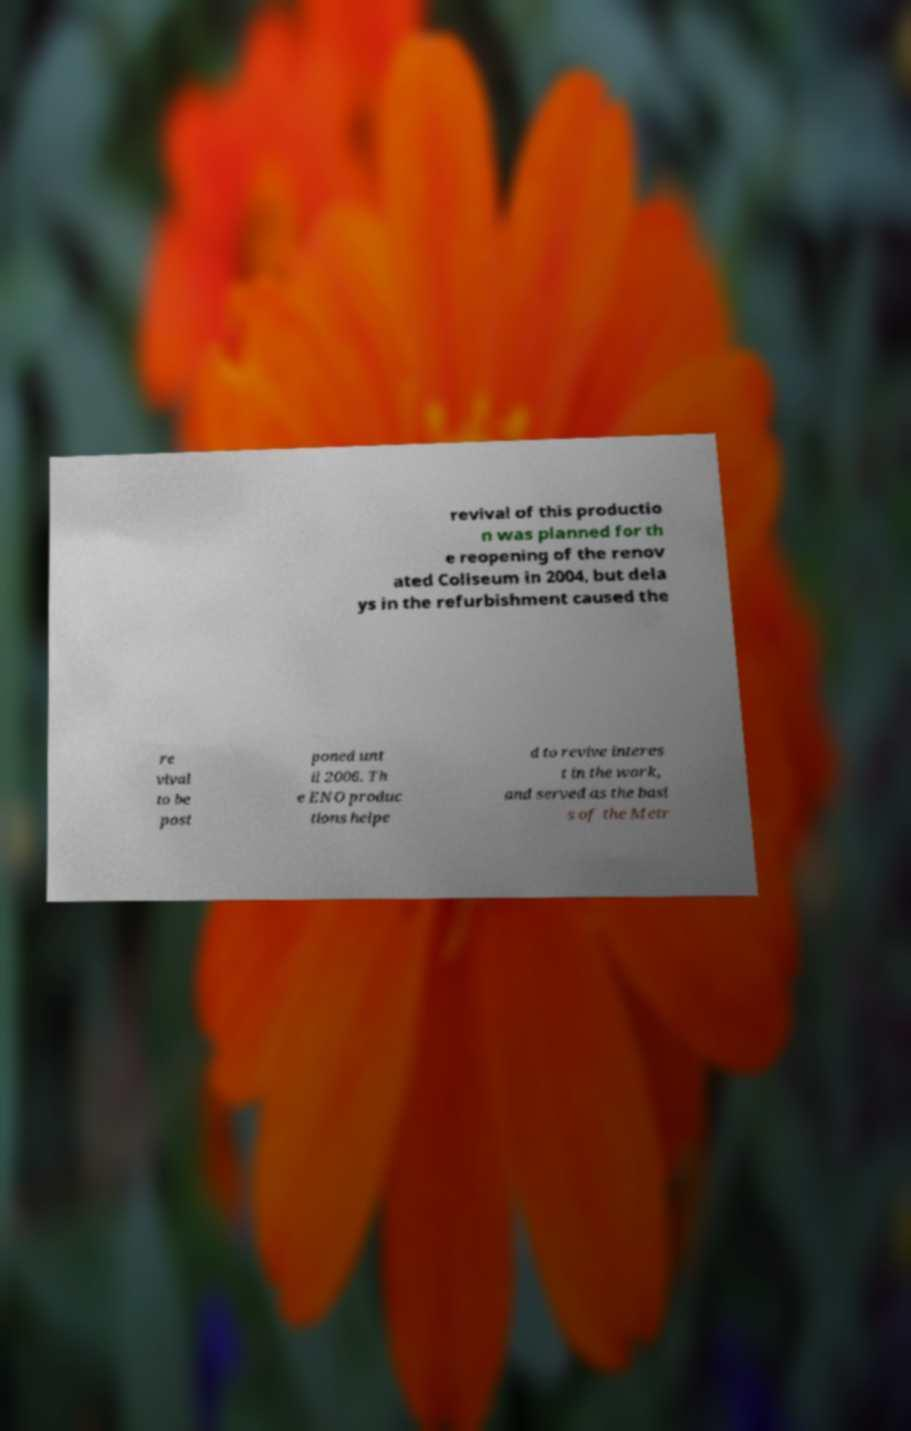For documentation purposes, I need the text within this image transcribed. Could you provide that? revival of this productio n was planned for th e reopening of the renov ated Coliseum in 2004, but dela ys in the refurbishment caused the re vival to be post poned unt il 2006. Th e ENO produc tions helpe d to revive interes t in the work, and served as the basi s of the Metr 